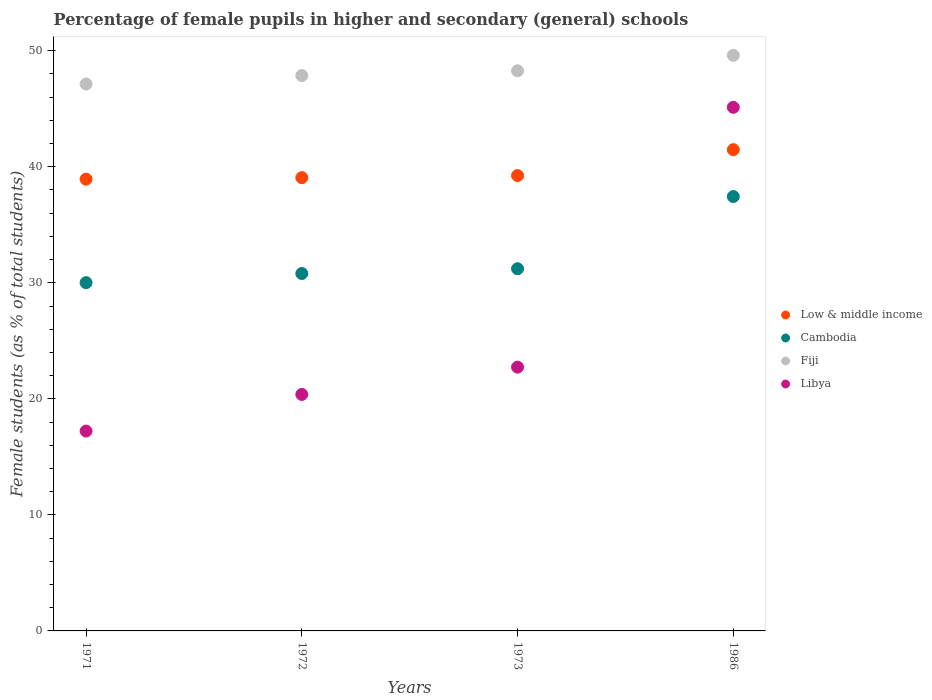Is the number of dotlines equal to the number of legend labels?
Make the answer very short. Yes. What is the percentage of female pupils in higher and secondary schools in Cambodia in 1972?
Your answer should be compact. 30.8. Across all years, what is the maximum percentage of female pupils in higher and secondary schools in Libya?
Offer a very short reply. 45.12. Across all years, what is the minimum percentage of female pupils in higher and secondary schools in Low & middle income?
Make the answer very short. 38.93. What is the total percentage of female pupils in higher and secondary schools in Libya in the graph?
Offer a terse response. 105.46. What is the difference between the percentage of female pupils in higher and secondary schools in Cambodia in 1971 and that in 1972?
Offer a terse response. -0.79. What is the difference between the percentage of female pupils in higher and secondary schools in Libya in 1971 and the percentage of female pupils in higher and secondary schools in Fiji in 1986?
Make the answer very short. -32.38. What is the average percentage of female pupils in higher and secondary schools in Low & middle income per year?
Ensure brevity in your answer.  39.68. In the year 1986, what is the difference between the percentage of female pupils in higher and secondary schools in Libya and percentage of female pupils in higher and secondary schools in Cambodia?
Keep it short and to the point. 7.69. In how many years, is the percentage of female pupils in higher and secondary schools in Low & middle income greater than 8 %?
Make the answer very short. 4. What is the ratio of the percentage of female pupils in higher and secondary schools in Cambodia in 1971 to that in 1973?
Provide a short and direct response. 0.96. Is the difference between the percentage of female pupils in higher and secondary schools in Libya in 1972 and 1973 greater than the difference between the percentage of female pupils in higher and secondary schools in Cambodia in 1972 and 1973?
Give a very brief answer. No. What is the difference between the highest and the second highest percentage of female pupils in higher and secondary schools in Libya?
Make the answer very short. 22.39. What is the difference between the highest and the lowest percentage of female pupils in higher and secondary schools in Fiji?
Offer a very short reply. 2.47. Is the sum of the percentage of female pupils in higher and secondary schools in Low & middle income in 1971 and 1973 greater than the maximum percentage of female pupils in higher and secondary schools in Fiji across all years?
Make the answer very short. Yes. Is it the case that in every year, the sum of the percentage of female pupils in higher and secondary schools in Cambodia and percentage of female pupils in higher and secondary schools in Fiji  is greater than the sum of percentage of female pupils in higher and secondary schools in Low & middle income and percentage of female pupils in higher and secondary schools in Libya?
Your answer should be very brief. Yes. Is it the case that in every year, the sum of the percentage of female pupils in higher and secondary schools in Cambodia and percentage of female pupils in higher and secondary schools in Low & middle income  is greater than the percentage of female pupils in higher and secondary schools in Libya?
Provide a succinct answer. Yes. Is the percentage of female pupils in higher and secondary schools in Cambodia strictly greater than the percentage of female pupils in higher and secondary schools in Libya over the years?
Your response must be concise. No. Is the percentage of female pupils in higher and secondary schools in Low & middle income strictly less than the percentage of female pupils in higher and secondary schools in Cambodia over the years?
Provide a short and direct response. No. What is the difference between two consecutive major ticks on the Y-axis?
Offer a very short reply. 10. Does the graph contain any zero values?
Offer a very short reply. No. Does the graph contain grids?
Your answer should be very brief. No. Where does the legend appear in the graph?
Your response must be concise. Center right. How many legend labels are there?
Your response must be concise. 4. How are the legend labels stacked?
Ensure brevity in your answer.  Vertical. What is the title of the graph?
Your answer should be compact. Percentage of female pupils in higher and secondary (general) schools. What is the label or title of the Y-axis?
Ensure brevity in your answer.  Female students (as % of total students). What is the Female students (as % of total students) of Low & middle income in 1971?
Provide a short and direct response. 38.93. What is the Female students (as % of total students) of Cambodia in 1971?
Your answer should be very brief. 30.01. What is the Female students (as % of total students) in Fiji in 1971?
Provide a short and direct response. 47.13. What is the Female students (as % of total students) of Libya in 1971?
Offer a very short reply. 17.22. What is the Female students (as % of total students) in Low & middle income in 1972?
Offer a very short reply. 39.06. What is the Female students (as % of total students) of Cambodia in 1972?
Offer a very short reply. 30.8. What is the Female students (as % of total students) in Fiji in 1972?
Keep it short and to the point. 47.86. What is the Female students (as % of total students) in Libya in 1972?
Your answer should be compact. 20.38. What is the Female students (as % of total students) in Low & middle income in 1973?
Give a very brief answer. 39.24. What is the Female students (as % of total students) of Cambodia in 1973?
Make the answer very short. 31.21. What is the Female students (as % of total students) of Fiji in 1973?
Your answer should be compact. 48.27. What is the Female students (as % of total students) of Libya in 1973?
Give a very brief answer. 22.73. What is the Female students (as % of total students) in Low & middle income in 1986?
Ensure brevity in your answer.  41.47. What is the Female students (as % of total students) of Cambodia in 1986?
Offer a very short reply. 37.44. What is the Female students (as % of total students) of Fiji in 1986?
Provide a succinct answer. 49.6. What is the Female students (as % of total students) of Libya in 1986?
Your answer should be compact. 45.12. Across all years, what is the maximum Female students (as % of total students) in Low & middle income?
Keep it short and to the point. 41.47. Across all years, what is the maximum Female students (as % of total students) in Cambodia?
Ensure brevity in your answer.  37.44. Across all years, what is the maximum Female students (as % of total students) in Fiji?
Provide a succinct answer. 49.6. Across all years, what is the maximum Female students (as % of total students) in Libya?
Your answer should be compact. 45.12. Across all years, what is the minimum Female students (as % of total students) in Low & middle income?
Provide a short and direct response. 38.93. Across all years, what is the minimum Female students (as % of total students) in Cambodia?
Keep it short and to the point. 30.01. Across all years, what is the minimum Female students (as % of total students) in Fiji?
Ensure brevity in your answer.  47.13. Across all years, what is the minimum Female students (as % of total students) of Libya?
Your response must be concise. 17.22. What is the total Female students (as % of total students) of Low & middle income in the graph?
Your response must be concise. 158.71. What is the total Female students (as % of total students) in Cambodia in the graph?
Offer a very short reply. 129.46. What is the total Female students (as % of total students) in Fiji in the graph?
Provide a succinct answer. 192.86. What is the total Female students (as % of total students) of Libya in the graph?
Offer a terse response. 105.46. What is the difference between the Female students (as % of total students) in Low & middle income in 1971 and that in 1972?
Offer a very short reply. -0.13. What is the difference between the Female students (as % of total students) in Cambodia in 1971 and that in 1972?
Keep it short and to the point. -0.79. What is the difference between the Female students (as % of total students) in Fiji in 1971 and that in 1972?
Your answer should be very brief. -0.73. What is the difference between the Female students (as % of total students) in Libya in 1971 and that in 1972?
Your answer should be very brief. -3.16. What is the difference between the Female students (as % of total students) in Low & middle income in 1971 and that in 1973?
Ensure brevity in your answer.  -0.31. What is the difference between the Female students (as % of total students) of Cambodia in 1971 and that in 1973?
Provide a succinct answer. -1.2. What is the difference between the Female students (as % of total students) in Fiji in 1971 and that in 1973?
Ensure brevity in your answer.  -1.14. What is the difference between the Female students (as % of total students) of Libya in 1971 and that in 1973?
Your answer should be very brief. -5.51. What is the difference between the Female students (as % of total students) of Low & middle income in 1971 and that in 1986?
Provide a short and direct response. -2.54. What is the difference between the Female students (as % of total students) of Cambodia in 1971 and that in 1986?
Your answer should be compact. -7.42. What is the difference between the Female students (as % of total students) in Fiji in 1971 and that in 1986?
Provide a short and direct response. -2.47. What is the difference between the Female students (as % of total students) in Libya in 1971 and that in 1986?
Give a very brief answer. -27.9. What is the difference between the Female students (as % of total students) of Low & middle income in 1972 and that in 1973?
Your response must be concise. -0.18. What is the difference between the Female students (as % of total students) of Cambodia in 1972 and that in 1973?
Your answer should be very brief. -0.41. What is the difference between the Female students (as % of total students) of Fiji in 1972 and that in 1973?
Your response must be concise. -0.41. What is the difference between the Female students (as % of total students) in Libya in 1972 and that in 1973?
Provide a short and direct response. -2.35. What is the difference between the Female students (as % of total students) of Low & middle income in 1972 and that in 1986?
Your answer should be very brief. -2.41. What is the difference between the Female students (as % of total students) of Cambodia in 1972 and that in 1986?
Keep it short and to the point. -6.63. What is the difference between the Female students (as % of total students) in Fiji in 1972 and that in 1986?
Give a very brief answer. -1.74. What is the difference between the Female students (as % of total students) in Libya in 1972 and that in 1986?
Give a very brief answer. -24.74. What is the difference between the Female students (as % of total students) of Low & middle income in 1973 and that in 1986?
Make the answer very short. -2.23. What is the difference between the Female students (as % of total students) in Cambodia in 1973 and that in 1986?
Make the answer very short. -6.22. What is the difference between the Female students (as % of total students) of Fiji in 1973 and that in 1986?
Your answer should be compact. -1.33. What is the difference between the Female students (as % of total students) of Libya in 1973 and that in 1986?
Offer a very short reply. -22.39. What is the difference between the Female students (as % of total students) of Low & middle income in 1971 and the Female students (as % of total students) of Cambodia in 1972?
Your answer should be compact. 8.13. What is the difference between the Female students (as % of total students) in Low & middle income in 1971 and the Female students (as % of total students) in Fiji in 1972?
Keep it short and to the point. -8.93. What is the difference between the Female students (as % of total students) in Low & middle income in 1971 and the Female students (as % of total students) in Libya in 1972?
Ensure brevity in your answer.  18.55. What is the difference between the Female students (as % of total students) in Cambodia in 1971 and the Female students (as % of total students) in Fiji in 1972?
Provide a succinct answer. -17.85. What is the difference between the Female students (as % of total students) of Cambodia in 1971 and the Female students (as % of total students) of Libya in 1972?
Your answer should be compact. 9.63. What is the difference between the Female students (as % of total students) of Fiji in 1971 and the Female students (as % of total students) of Libya in 1972?
Offer a terse response. 26.75. What is the difference between the Female students (as % of total students) of Low & middle income in 1971 and the Female students (as % of total students) of Cambodia in 1973?
Give a very brief answer. 7.72. What is the difference between the Female students (as % of total students) in Low & middle income in 1971 and the Female students (as % of total students) in Fiji in 1973?
Your answer should be very brief. -9.34. What is the difference between the Female students (as % of total students) of Low & middle income in 1971 and the Female students (as % of total students) of Libya in 1973?
Offer a very short reply. 16.2. What is the difference between the Female students (as % of total students) in Cambodia in 1971 and the Female students (as % of total students) in Fiji in 1973?
Provide a succinct answer. -18.26. What is the difference between the Female students (as % of total students) in Cambodia in 1971 and the Female students (as % of total students) in Libya in 1973?
Ensure brevity in your answer.  7.28. What is the difference between the Female students (as % of total students) of Fiji in 1971 and the Female students (as % of total students) of Libya in 1973?
Give a very brief answer. 24.4. What is the difference between the Female students (as % of total students) in Low & middle income in 1971 and the Female students (as % of total students) in Cambodia in 1986?
Give a very brief answer. 1.5. What is the difference between the Female students (as % of total students) of Low & middle income in 1971 and the Female students (as % of total students) of Fiji in 1986?
Offer a terse response. -10.67. What is the difference between the Female students (as % of total students) of Low & middle income in 1971 and the Female students (as % of total students) of Libya in 1986?
Your answer should be compact. -6.19. What is the difference between the Female students (as % of total students) of Cambodia in 1971 and the Female students (as % of total students) of Fiji in 1986?
Provide a short and direct response. -19.59. What is the difference between the Female students (as % of total students) of Cambodia in 1971 and the Female students (as % of total students) of Libya in 1986?
Ensure brevity in your answer.  -15.11. What is the difference between the Female students (as % of total students) in Fiji in 1971 and the Female students (as % of total students) in Libya in 1986?
Your answer should be compact. 2.01. What is the difference between the Female students (as % of total students) of Low & middle income in 1972 and the Female students (as % of total students) of Cambodia in 1973?
Keep it short and to the point. 7.85. What is the difference between the Female students (as % of total students) in Low & middle income in 1972 and the Female students (as % of total students) in Fiji in 1973?
Your answer should be very brief. -9.21. What is the difference between the Female students (as % of total students) in Low & middle income in 1972 and the Female students (as % of total students) in Libya in 1973?
Offer a very short reply. 16.33. What is the difference between the Female students (as % of total students) of Cambodia in 1972 and the Female students (as % of total students) of Fiji in 1973?
Give a very brief answer. -17.47. What is the difference between the Female students (as % of total students) in Cambodia in 1972 and the Female students (as % of total students) in Libya in 1973?
Provide a short and direct response. 8.07. What is the difference between the Female students (as % of total students) of Fiji in 1972 and the Female students (as % of total students) of Libya in 1973?
Your response must be concise. 25.13. What is the difference between the Female students (as % of total students) of Low & middle income in 1972 and the Female students (as % of total students) of Cambodia in 1986?
Offer a very short reply. 1.63. What is the difference between the Female students (as % of total students) of Low & middle income in 1972 and the Female students (as % of total students) of Fiji in 1986?
Your answer should be compact. -10.54. What is the difference between the Female students (as % of total students) in Low & middle income in 1972 and the Female students (as % of total students) in Libya in 1986?
Provide a short and direct response. -6.06. What is the difference between the Female students (as % of total students) in Cambodia in 1972 and the Female students (as % of total students) in Fiji in 1986?
Your answer should be compact. -18.8. What is the difference between the Female students (as % of total students) of Cambodia in 1972 and the Female students (as % of total students) of Libya in 1986?
Ensure brevity in your answer.  -14.32. What is the difference between the Female students (as % of total students) of Fiji in 1972 and the Female students (as % of total students) of Libya in 1986?
Give a very brief answer. 2.74. What is the difference between the Female students (as % of total students) of Low & middle income in 1973 and the Female students (as % of total students) of Cambodia in 1986?
Give a very brief answer. 1.81. What is the difference between the Female students (as % of total students) in Low & middle income in 1973 and the Female students (as % of total students) in Fiji in 1986?
Keep it short and to the point. -10.36. What is the difference between the Female students (as % of total students) of Low & middle income in 1973 and the Female students (as % of total students) of Libya in 1986?
Keep it short and to the point. -5.88. What is the difference between the Female students (as % of total students) in Cambodia in 1973 and the Female students (as % of total students) in Fiji in 1986?
Provide a short and direct response. -18.39. What is the difference between the Female students (as % of total students) of Cambodia in 1973 and the Female students (as % of total students) of Libya in 1986?
Offer a terse response. -13.91. What is the difference between the Female students (as % of total students) of Fiji in 1973 and the Female students (as % of total students) of Libya in 1986?
Keep it short and to the point. 3.15. What is the average Female students (as % of total students) of Low & middle income per year?
Keep it short and to the point. 39.68. What is the average Female students (as % of total students) of Cambodia per year?
Offer a terse response. 32.37. What is the average Female students (as % of total students) in Fiji per year?
Make the answer very short. 48.22. What is the average Female students (as % of total students) of Libya per year?
Your answer should be very brief. 26.36. In the year 1971, what is the difference between the Female students (as % of total students) of Low & middle income and Female students (as % of total students) of Cambodia?
Your answer should be compact. 8.92. In the year 1971, what is the difference between the Female students (as % of total students) of Low & middle income and Female students (as % of total students) of Fiji?
Offer a terse response. -8.2. In the year 1971, what is the difference between the Female students (as % of total students) in Low & middle income and Female students (as % of total students) in Libya?
Offer a very short reply. 21.71. In the year 1971, what is the difference between the Female students (as % of total students) in Cambodia and Female students (as % of total students) in Fiji?
Ensure brevity in your answer.  -17.12. In the year 1971, what is the difference between the Female students (as % of total students) of Cambodia and Female students (as % of total students) of Libya?
Give a very brief answer. 12.79. In the year 1971, what is the difference between the Female students (as % of total students) of Fiji and Female students (as % of total students) of Libya?
Offer a terse response. 29.91. In the year 1972, what is the difference between the Female students (as % of total students) in Low & middle income and Female students (as % of total students) in Cambodia?
Your answer should be very brief. 8.26. In the year 1972, what is the difference between the Female students (as % of total students) of Low & middle income and Female students (as % of total students) of Fiji?
Offer a terse response. -8.8. In the year 1972, what is the difference between the Female students (as % of total students) of Low & middle income and Female students (as % of total students) of Libya?
Make the answer very short. 18.68. In the year 1972, what is the difference between the Female students (as % of total students) of Cambodia and Female students (as % of total students) of Fiji?
Offer a very short reply. -17.06. In the year 1972, what is the difference between the Female students (as % of total students) of Cambodia and Female students (as % of total students) of Libya?
Your answer should be compact. 10.42. In the year 1972, what is the difference between the Female students (as % of total students) of Fiji and Female students (as % of total students) of Libya?
Give a very brief answer. 27.48. In the year 1973, what is the difference between the Female students (as % of total students) in Low & middle income and Female students (as % of total students) in Cambodia?
Your response must be concise. 8.03. In the year 1973, what is the difference between the Female students (as % of total students) of Low & middle income and Female students (as % of total students) of Fiji?
Your answer should be compact. -9.03. In the year 1973, what is the difference between the Female students (as % of total students) of Low & middle income and Female students (as % of total students) of Libya?
Your answer should be very brief. 16.51. In the year 1973, what is the difference between the Female students (as % of total students) in Cambodia and Female students (as % of total students) in Fiji?
Make the answer very short. -17.06. In the year 1973, what is the difference between the Female students (as % of total students) in Cambodia and Female students (as % of total students) in Libya?
Make the answer very short. 8.48. In the year 1973, what is the difference between the Female students (as % of total students) of Fiji and Female students (as % of total students) of Libya?
Your response must be concise. 25.54. In the year 1986, what is the difference between the Female students (as % of total students) of Low & middle income and Female students (as % of total students) of Cambodia?
Give a very brief answer. 4.04. In the year 1986, what is the difference between the Female students (as % of total students) in Low & middle income and Female students (as % of total students) in Fiji?
Provide a short and direct response. -8.13. In the year 1986, what is the difference between the Female students (as % of total students) of Low & middle income and Female students (as % of total students) of Libya?
Make the answer very short. -3.65. In the year 1986, what is the difference between the Female students (as % of total students) of Cambodia and Female students (as % of total students) of Fiji?
Offer a terse response. -12.17. In the year 1986, what is the difference between the Female students (as % of total students) of Cambodia and Female students (as % of total students) of Libya?
Make the answer very short. -7.69. In the year 1986, what is the difference between the Female students (as % of total students) of Fiji and Female students (as % of total students) of Libya?
Your response must be concise. 4.48. What is the ratio of the Female students (as % of total students) in Low & middle income in 1971 to that in 1972?
Make the answer very short. 1. What is the ratio of the Female students (as % of total students) of Cambodia in 1971 to that in 1972?
Provide a succinct answer. 0.97. What is the ratio of the Female students (as % of total students) in Fiji in 1971 to that in 1972?
Provide a succinct answer. 0.98. What is the ratio of the Female students (as % of total students) of Libya in 1971 to that in 1972?
Your answer should be very brief. 0.84. What is the ratio of the Female students (as % of total students) of Cambodia in 1971 to that in 1973?
Ensure brevity in your answer.  0.96. What is the ratio of the Female students (as % of total students) of Fiji in 1971 to that in 1973?
Your response must be concise. 0.98. What is the ratio of the Female students (as % of total students) in Libya in 1971 to that in 1973?
Provide a succinct answer. 0.76. What is the ratio of the Female students (as % of total students) in Low & middle income in 1971 to that in 1986?
Your answer should be compact. 0.94. What is the ratio of the Female students (as % of total students) of Cambodia in 1971 to that in 1986?
Offer a terse response. 0.8. What is the ratio of the Female students (as % of total students) of Fiji in 1971 to that in 1986?
Ensure brevity in your answer.  0.95. What is the ratio of the Female students (as % of total students) in Libya in 1971 to that in 1986?
Ensure brevity in your answer.  0.38. What is the ratio of the Female students (as % of total students) in Low & middle income in 1972 to that in 1973?
Keep it short and to the point. 1. What is the ratio of the Female students (as % of total students) of Cambodia in 1972 to that in 1973?
Make the answer very short. 0.99. What is the ratio of the Female students (as % of total students) of Fiji in 1972 to that in 1973?
Give a very brief answer. 0.99. What is the ratio of the Female students (as % of total students) of Libya in 1972 to that in 1973?
Your answer should be very brief. 0.9. What is the ratio of the Female students (as % of total students) in Low & middle income in 1972 to that in 1986?
Your response must be concise. 0.94. What is the ratio of the Female students (as % of total students) in Cambodia in 1972 to that in 1986?
Offer a terse response. 0.82. What is the ratio of the Female students (as % of total students) in Fiji in 1972 to that in 1986?
Ensure brevity in your answer.  0.96. What is the ratio of the Female students (as % of total students) of Libya in 1972 to that in 1986?
Make the answer very short. 0.45. What is the ratio of the Female students (as % of total students) in Low & middle income in 1973 to that in 1986?
Your answer should be compact. 0.95. What is the ratio of the Female students (as % of total students) in Cambodia in 1973 to that in 1986?
Your answer should be compact. 0.83. What is the ratio of the Female students (as % of total students) in Fiji in 1973 to that in 1986?
Keep it short and to the point. 0.97. What is the ratio of the Female students (as % of total students) in Libya in 1973 to that in 1986?
Ensure brevity in your answer.  0.5. What is the difference between the highest and the second highest Female students (as % of total students) of Low & middle income?
Keep it short and to the point. 2.23. What is the difference between the highest and the second highest Female students (as % of total students) of Cambodia?
Keep it short and to the point. 6.22. What is the difference between the highest and the second highest Female students (as % of total students) in Fiji?
Your answer should be compact. 1.33. What is the difference between the highest and the second highest Female students (as % of total students) in Libya?
Make the answer very short. 22.39. What is the difference between the highest and the lowest Female students (as % of total students) in Low & middle income?
Give a very brief answer. 2.54. What is the difference between the highest and the lowest Female students (as % of total students) of Cambodia?
Provide a short and direct response. 7.42. What is the difference between the highest and the lowest Female students (as % of total students) of Fiji?
Your answer should be very brief. 2.47. What is the difference between the highest and the lowest Female students (as % of total students) in Libya?
Make the answer very short. 27.9. 